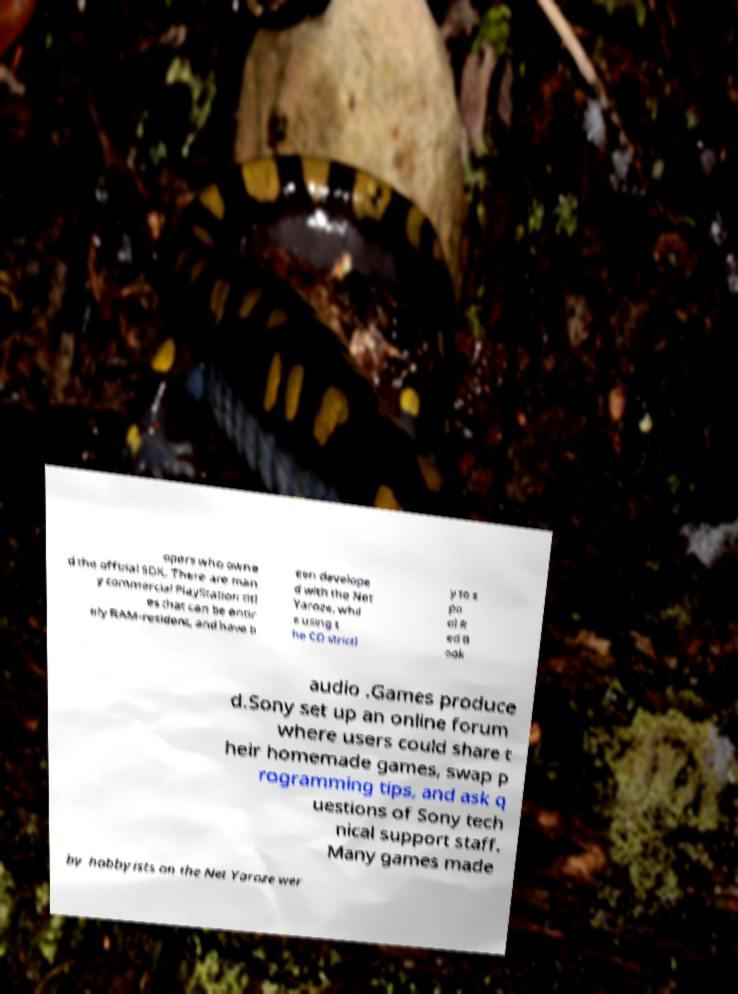Can you accurately transcribe the text from the provided image for me? opers who owne d the official SDK. There are man y commercial PlayStation titl es that can be entir ely RAM-resident, and have b een develope d with the Net Yaroze, whil e using t he CD strictl y to s po ol R ed B ook audio .Games produce d.Sony set up an online forum where users could share t heir homemade games, swap p rogramming tips, and ask q uestions of Sony tech nical support staff. Many games made by hobbyists on the Net Yaroze wer 